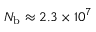<formula> <loc_0><loc_0><loc_500><loc_500>N _ { b } \approx 2 . 3 \times 1 0 ^ { 7 }</formula> 